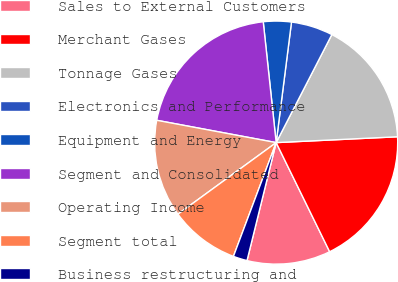Convert chart to OTSL. <chart><loc_0><loc_0><loc_500><loc_500><pie_chart><fcel>Sales to External Customers<fcel>Merchant Gases<fcel>Tonnage Gases<fcel>Electronics and Performance<fcel>Equipment and Energy<fcel>Segment and Consolidated<fcel>Operating Income<fcel>Segment total<fcel>Business restructuring and<nl><fcel>11.11%<fcel>18.51%<fcel>16.66%<fcel>5.56%<fcel>3.71%<fcel>20.36%<fcel>12.96%<fcel>9.26%<fcel>1.86%<nl></chart> 